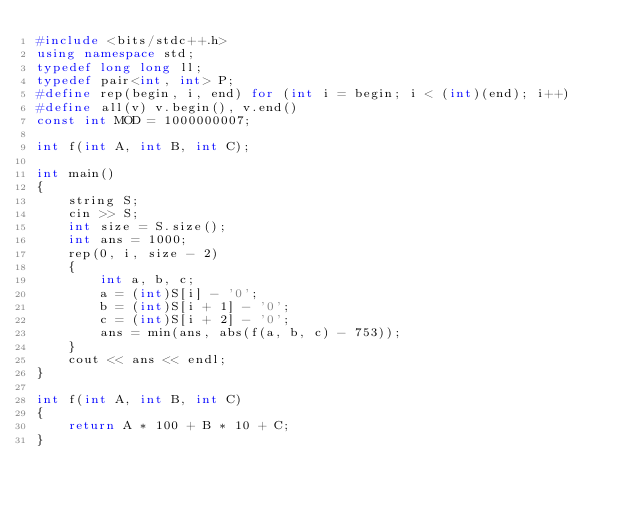Convert code to text. <code><loc_0><loc_0><loc_500><loc_500><_C++_>#include <bits/stdc++.h>
using namespace std;
typedef long long ll;
typedef pair<int, int> P;
#define rep(begin, i, end) for (int i = begin; i < (int)(end); i++)
#define all(v) v.begin(), v.end()
const int MOD = 1000000007;

int f(int A, int B, int C);

int main()
{
    string S;
    cin >> S;
    int size = S.size();
    int ans = 1000;
    rep(0, i, size - 2)
    {
        int a, b, c;
        a = (int)S[i] - '0';
        b = (int)S[i + 1] - '0';
        c = (int)S[i + 2] - '0';
        ans = min(ans, abs(f(a, b, c) - 753));
    }
    cout << ans << endl;
}

int f(int A, int B, int C)
{
    return A * 100 + B * 10 + C;
}</code> 